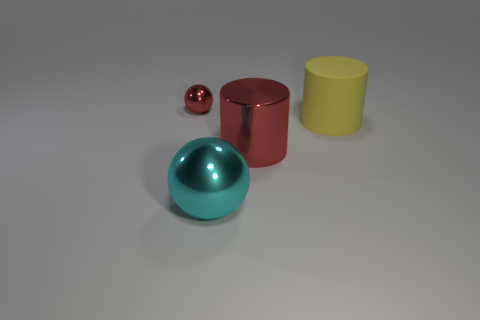Add 4 green objects. How many objects exist? 8 Add 2 tiny gray cylinders. How many tiny gray cylinders exist? 2 Subtract 0 purple blocks. How many objects are left? 4 Subtract all large gray metal cubes. Subtract all large yellow matte objects. How many objects are left? 3 Add 4 spheres. How many spheres are left? 6 